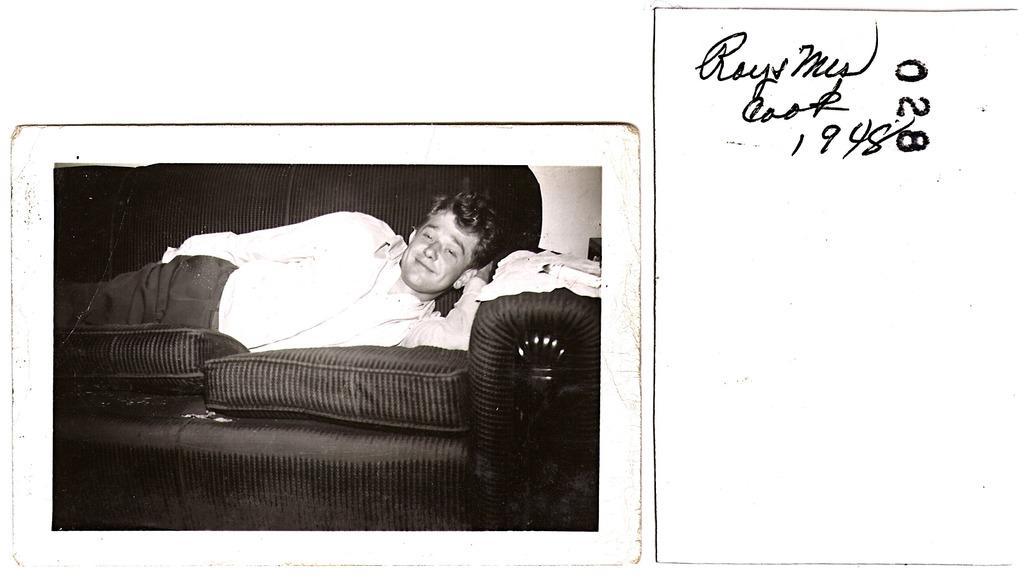Could you give a brief overview of what you see in this image? In the image we can see a paper, on the paper we can see some text. In the bottom left corner of the image we can see a couch, in the couch a person is lying and smiling. 